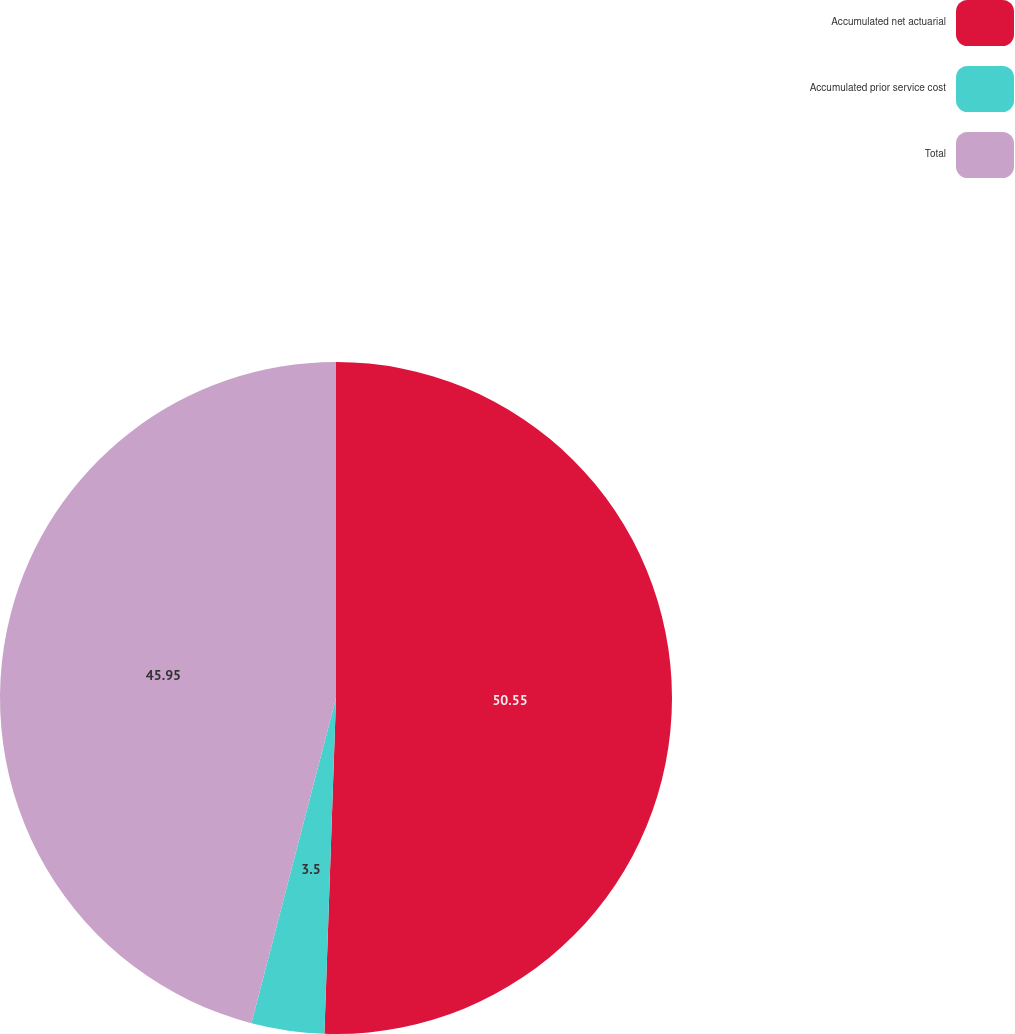<chart> <loc_0><loc_0><loc_500><loc_500><pie_chart><fcel>Accumulated net actuarial<fcel>Accumulated prior service cost<fcel>Total<nl><fcel>50.55%<fcel>3.5%<fcel>45.95%<nl></chart> 